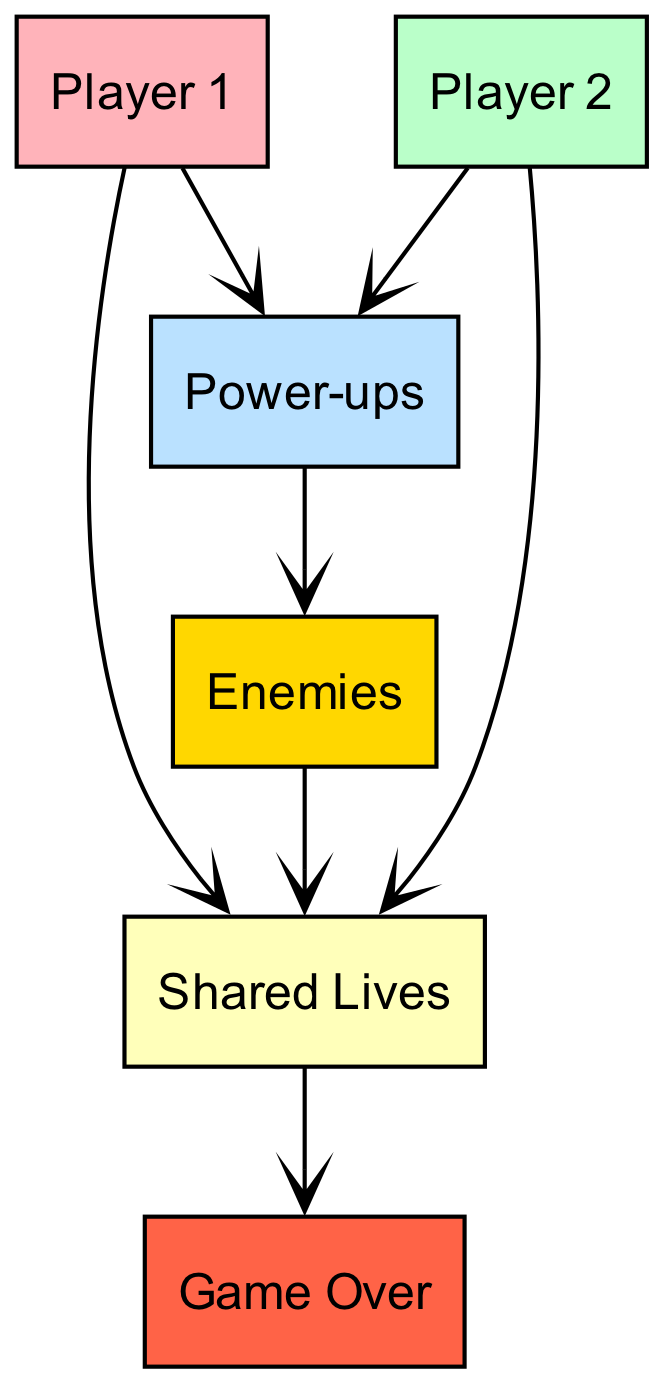What are the two players in the diagram? The diagram identifies two individual players, specifically labeled as Player 1 and Player 2.
Answer: Player 1, Player 2 How many total elements are shown in the diagram? There are six distinct elements illustrated in the diagram: Player 1, Player 2, Power-ups, Shared Lives, Enemies, and Game Over.
Answer: Six What do Player 1 and Player 2 consume? Both Player 1 and Player 2 consume two resources: Power-ups and Shared Lives.
Answer: Power-ups, Shared Lives What consumes Shared Lives? The element that consumes Shared Lives is Enemies, as indicated by the directed arrow pointing towards Shared Lives from Enemies.
Answer: Enemies Which element does Power-ups consume? According to the diagram, Power-ups consume Enemies, as shown by the directed relationship from Power-ups to Enemies.
Answer: Enemies What is the end point of the food chain in this diagram? The end point, meaning the element that does not consume anything further, is Game Over, as it has no outgoing connections to other elements.
Answer: Game Over Which two elements share a direct connection with Player 1? Player 1 has direct connections to two elements, namely Power-ups and Shared Lives, both of which it consumes.
Answer: Power-ups, Shared Lives If both players reach Game Over, which element does this directly flow from? The flow towards Game Over comes directly from Shared Lives, indicating that if Shared Lives are depleted, it leads to Game Over.
Answer: Shared Lives What can be inferred if there are no enemies in the game? If there are no enemies present, then Power-ups cannot be consumed because they rely on enemies for their existence, which would impact both players' gameplay negatively.
Answer: Power-ups 